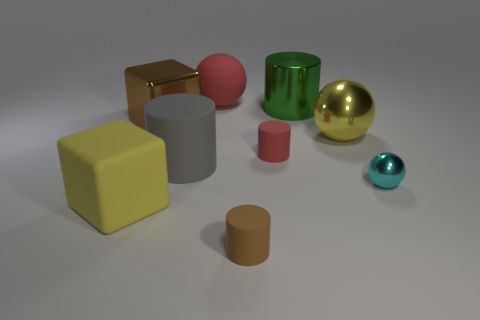How many brown objects are in front of the cyan metallic thing and on the left side of the large rubber cylinder?
Make the answer very short. 0. There is a brown block; how many things are to the left of it?
Your response must be concise. 1. Are there any big yellow rubber objects that have the same shape as the brown rubber object?
Your answer should be compact. No. Is the shape of the big red rubber thing the same as the yellow thing behind the red cylinder?
Your answer should be very brief. Yes. How many cylinders are big gray matte objects or green rubber objects?
Ensure brevity in your answer.  1. The tiny rubber thing that is left of the tiny red rubber cylinder has what shape?
Offer a terse response. Cylinder. What number of large green things have the same material as the small brown cylinder?
Your answer should be compact. 0. Are there fewer big metal cylinders in front of the big shiny cylinder than gray blocks?
Make the answer very short. No. How big is the object behind the cylinder that is behind the yellow metal sphere?
Make the answer very short. Large. Is the color of the metallic cylinder the same as the big block that is behind the cyan thing?
Provide a short and direct response. No. 